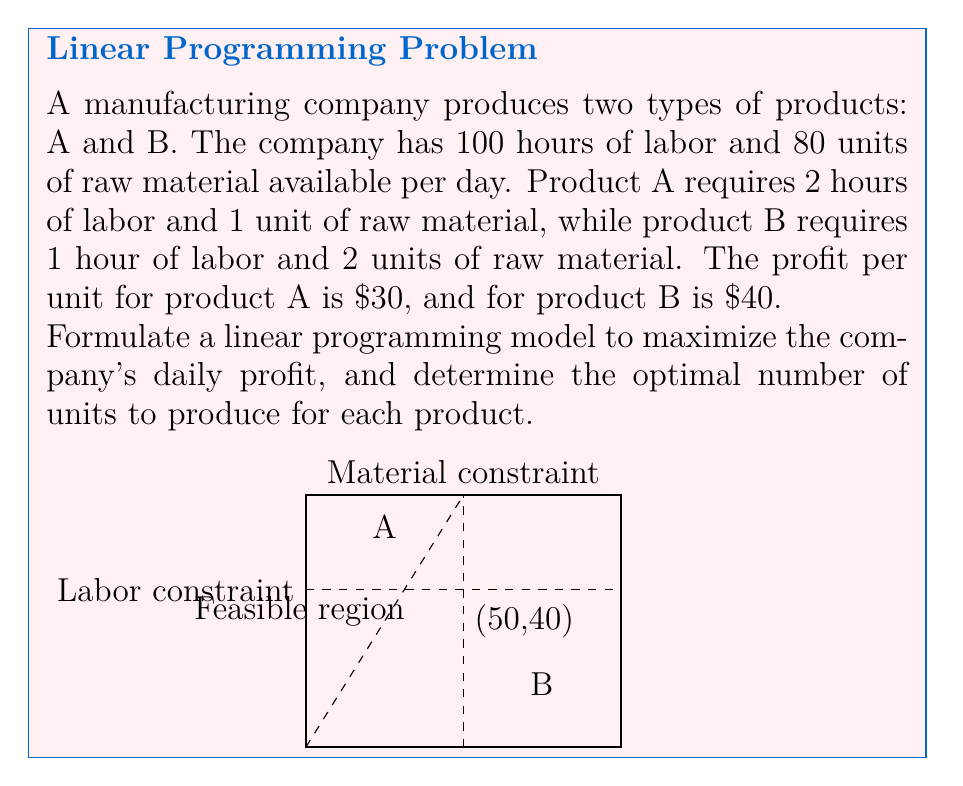Show me your answer to this math problem. Let's approach this step-by-step:

1) Define variables:
   Let $x$ be the number of units of product A
   Let $y$ be the number of units of product B

2) Formulate the objective function:
   Maximize $Z = 30x + 40y$ (profit function)

3) Identify constraints:
   Labor constraint: $2x + y \leq 100$
   Raw material constraint: $x + 2y \leq 80$
   Non-negativity: $x \geq 0$, $y \geq 0$

4) The complete linear programming model:

   Maximize $Z = 30x + 40y$
   Subject to:
   $2x + y \leq 100$
   $x + 2y \leq 80$
   $x \geq 0$, $y \geq 0$

5) To solve, we can use the graphical method or simplex algorithm. From the graph, we can see that the optimal solution lies at the intersection of the two constraint lines.

6) Solve the system of equations:
   $2x + y = 100$
   $x + 2y = 80$

   Multiply the second equation by 2: $2x + 4y = 160$
   Subtract the first equation: $3y = 60$
   $y = 20$

   Substitute back into $x + 2y = 80$:
   $x + 2(20) = 80$
   $x = 40$

7) Therefore, the optimal solution is to produce 40 units of product A and 20 units of product B.

8) The maximum daily profit is:
   $Z = 30(40) + 40(20) = 1200 + 800 = 2000$
Answer: Produce 40 units of A and 20 units of B for a maximum daily profit of $2000. 